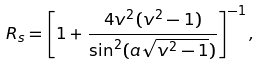Convert formula to latex. <formula><loc_0><loc_0><loc_500><loc_500>R _ { s } = \left [ 1 + \frac { 4 v ^ { 2 } ( v ^ { 2 } - 1 ) } { \sin ^ { 2 } ( a \sqrt { v ^ { 2 } - 1 } ) } \right ] ^ { - 1 } ,</formula> 